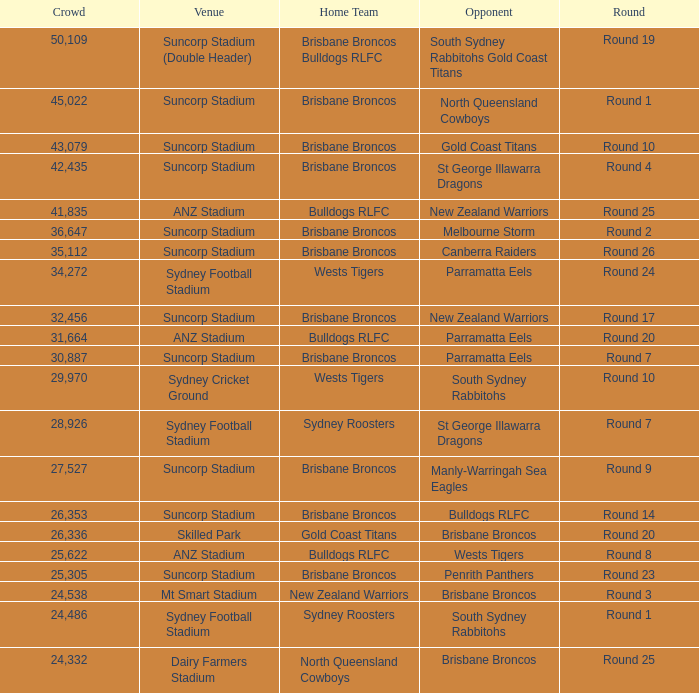How many people attended round 9? 1.0. 